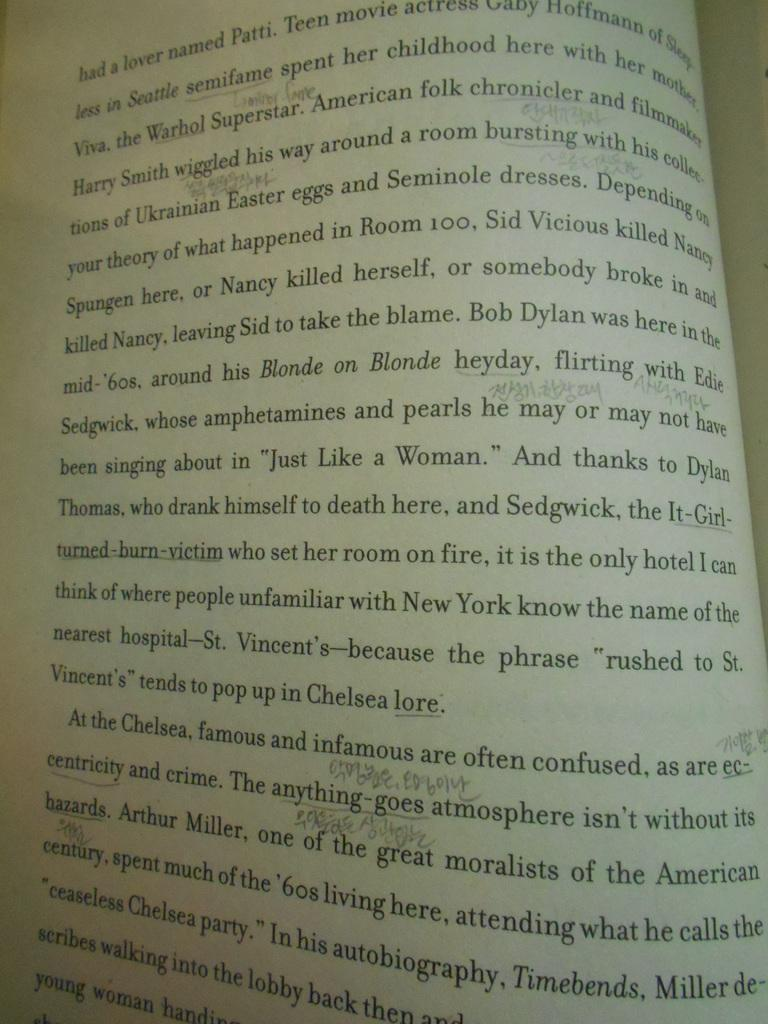<image>
Offer a succinct explanation of the picture presented. A page of a book can be seen with the first few words as "had a lover". 